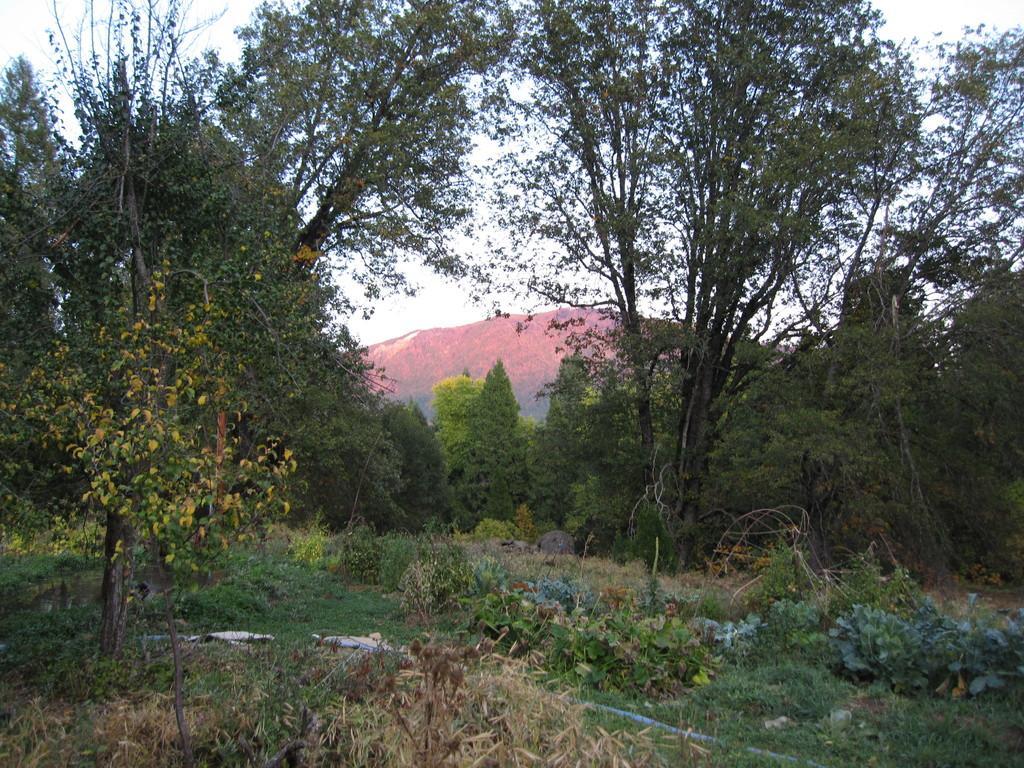Please provide a concise description of this image. In this picture we can see few trees and a hill. 